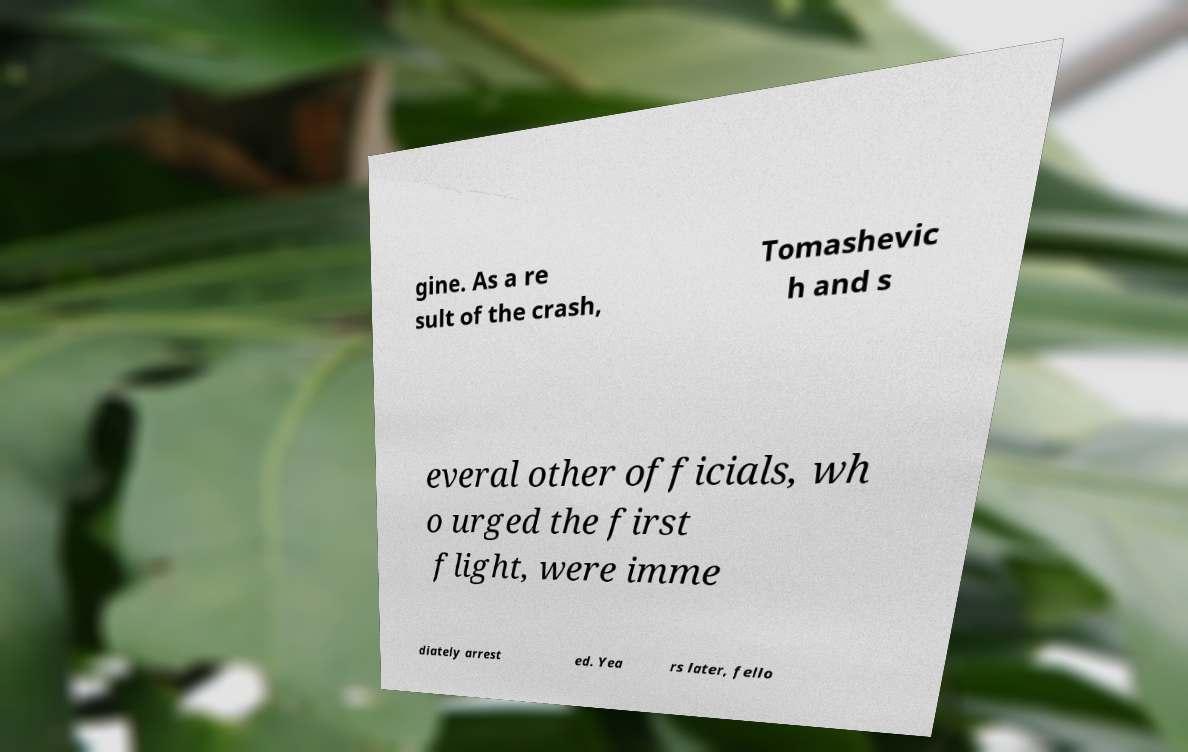What messages or text are displayed in this image? I need them in a readable, typed format. gine. As a re sult of the crash, Tomashevic h and s everal other officials, wh o urged the first flight, were imme diately arrest ed. Yea rs later, fello 